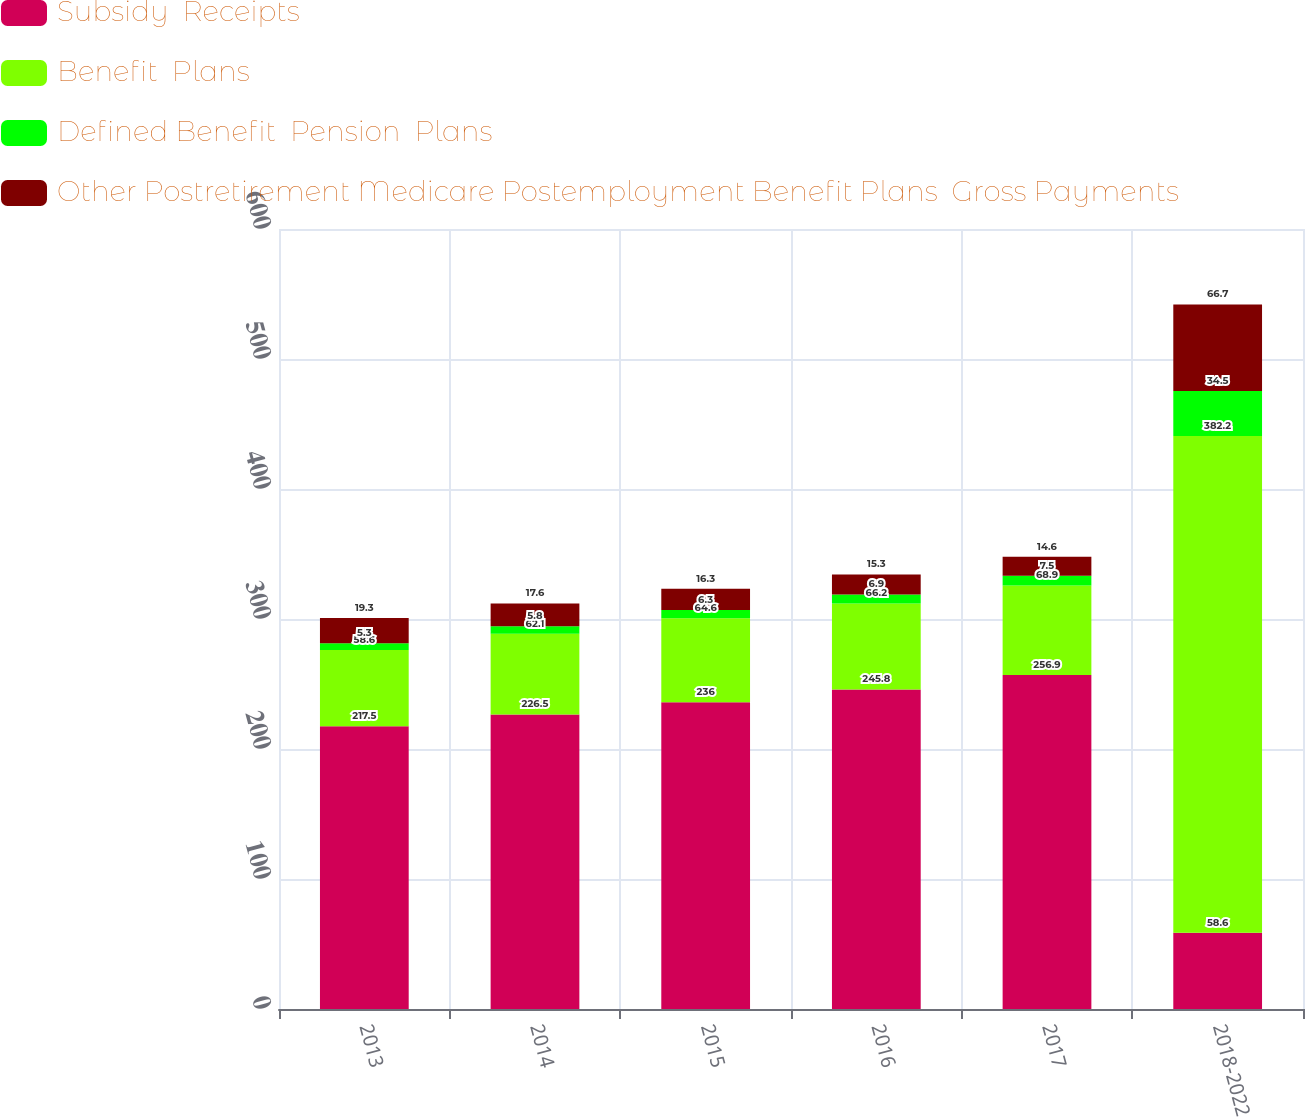<chart> <loc_0><loc_0><loc_500><loc_500><stacked_bar_chart><ecel><fcel>2013<fcel>2014<fcel>2015<fcel>2016<fcel>2017<fcel>2018-2022<nl><fcel>Subsidy  Receipts<fcel>217.5<fcel>226.5<fcel>236<fcel>245.8<fcel>256.9<fcel>58.6<nl><fcel>Benefit  Plans<fcel>58.6<fcel>62.1<fcel>64.6<fcel>66.2<fcel>68.9<fcel>382.2<nl><fcel>Defined Benefit  Pension  Plans<fcel>5.3<fcel>5.8<fcel>6.3<fcel>6.9<fcel>7.5<fcel>34.5<nl><fcel>Other Postretirement Medicare Postemployment Benefit Plans  Gross Payments<fcel>19.3<fcel>17.6<fcel>16.3<fcel>15.3<fcel>14.6<fcel>66.7<nl></chart> 